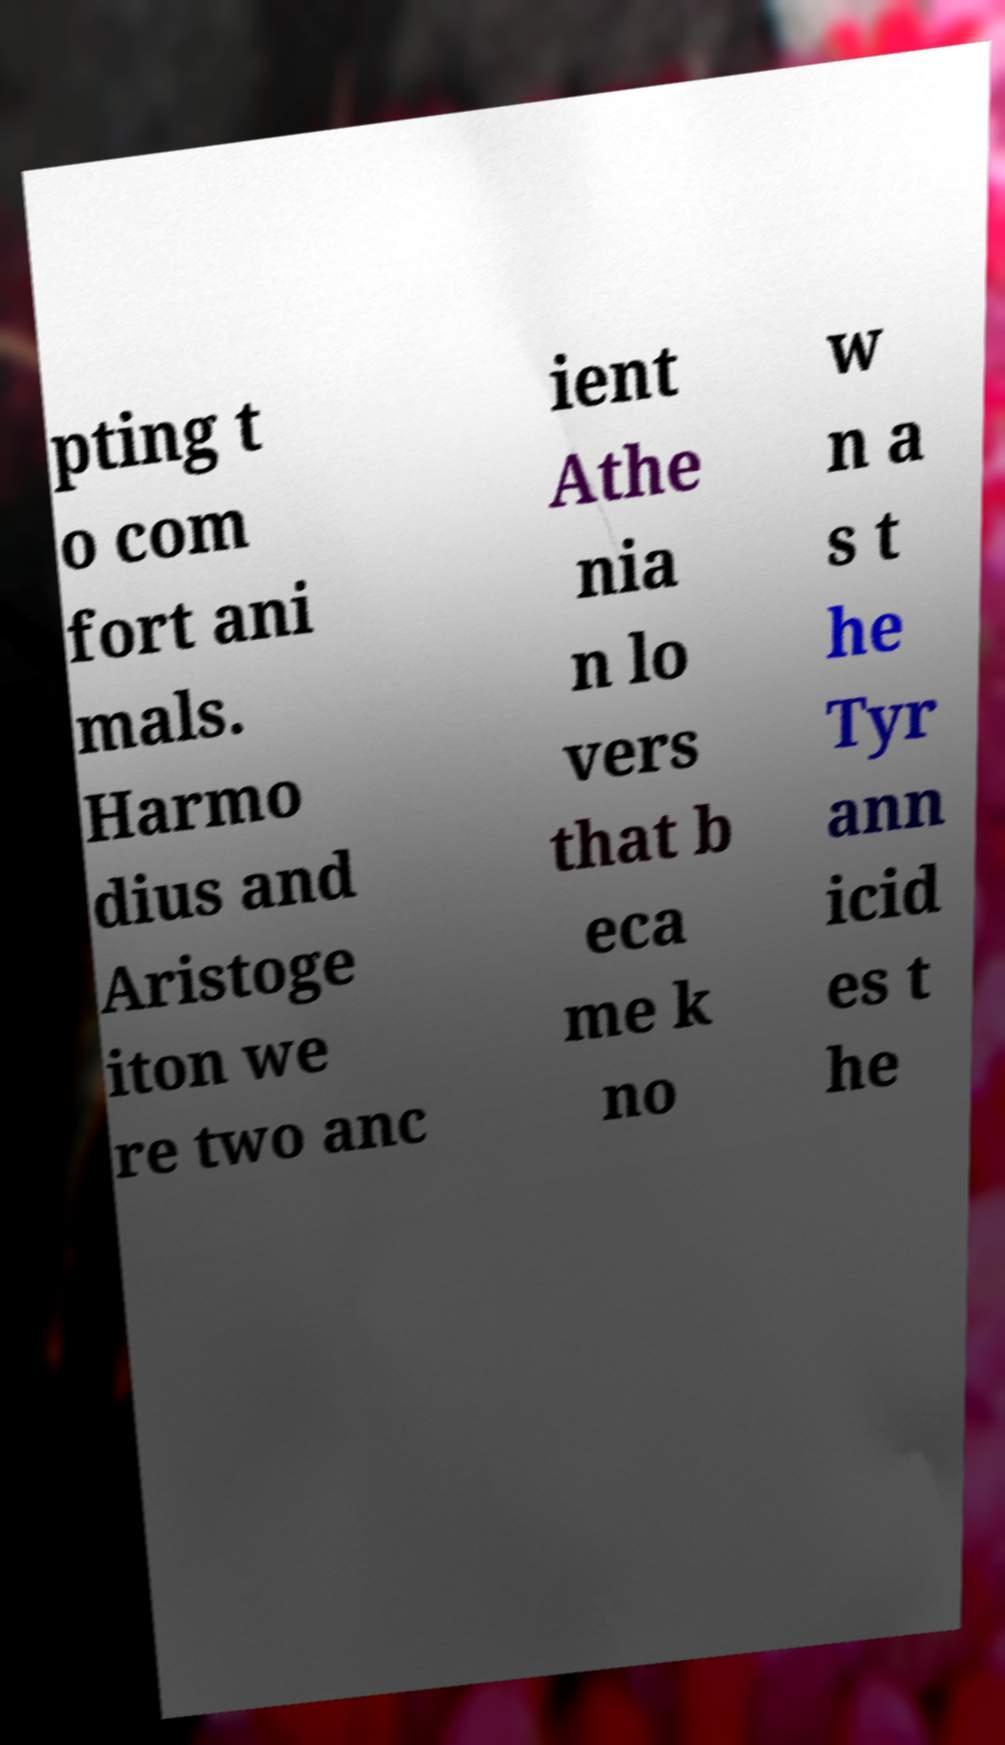Can you read and provide the text displayed in the image?This photo seems to have some interesting text. Can you extract and type it out for me? pting t o com fort ani mals. Harmo dius and Aristoge iton we re two anc ient Athe nia n lo vers that b eca me k no w n a s t he Tyr ann icid es t he 